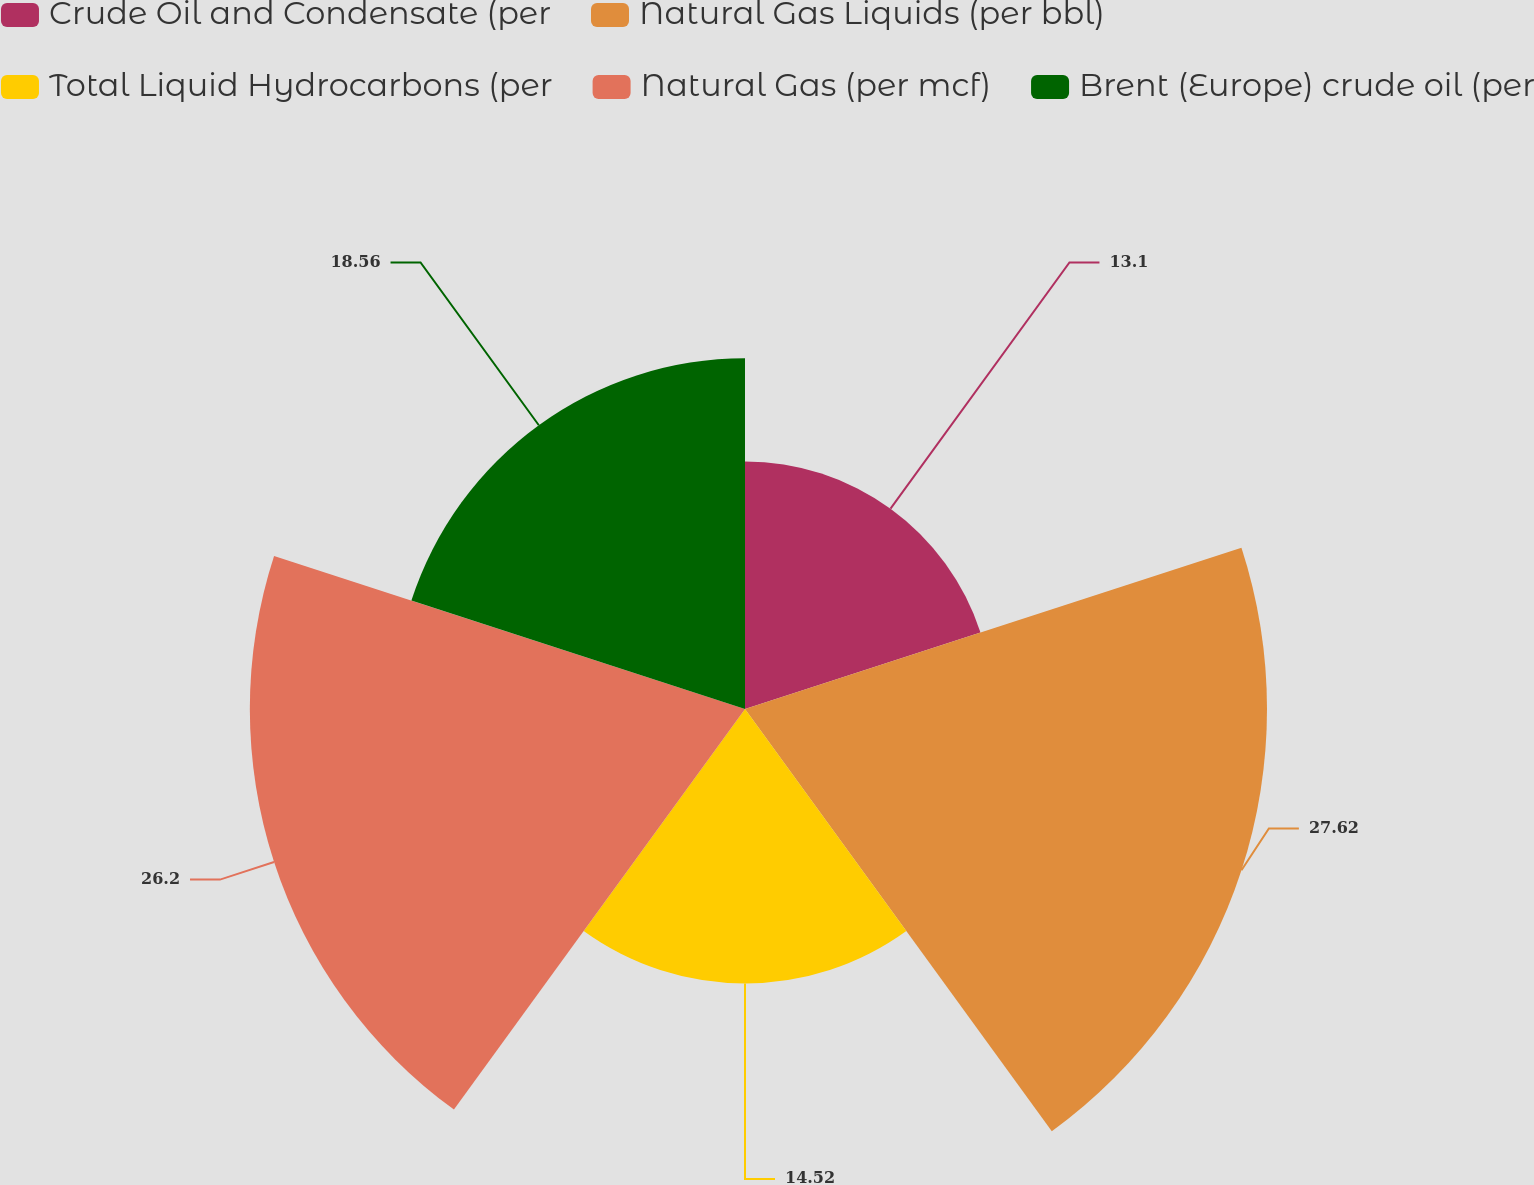Convert chart to OTSL. <chart><loc_0><loc_0><loc_500><loc_500><pie_chart><fcel>Crude Oil and Condensate (per<fcel>Natural Gas Liquids (per bbl)<fcel>Total Liquid Hydrocarbons (per<fcel>Natural Gas (per mcf)<fcel>Brent (Europe) crude oil (per<nl><fcel>13.1%<fcel>27.62%<fcel>14.52%<fcel>26.2%<fcel>18.56%<nl></chart> 